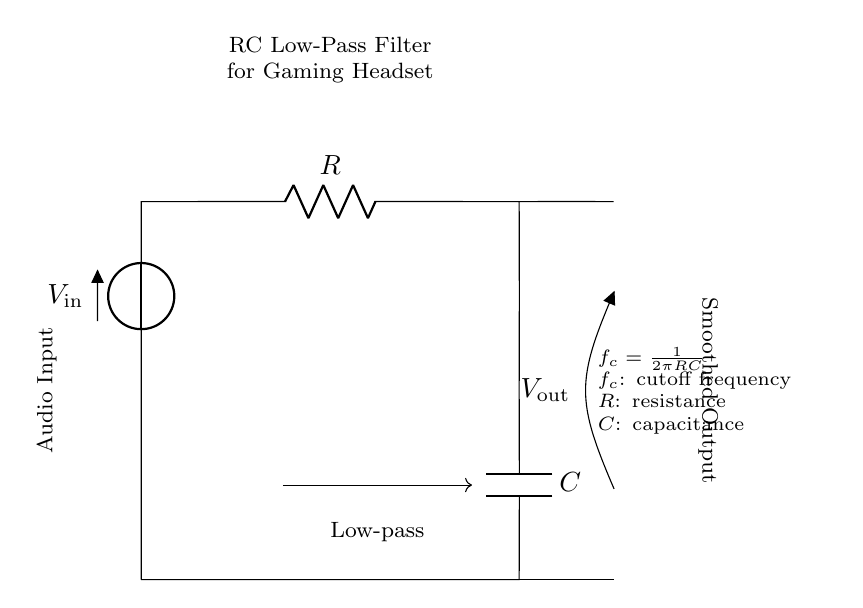What is the component labeled R in the circuit? The component labeled R represents a resistor, which is used to limit the flow of current and create a voltage drop in the circuit.
Answer: Resistor What does the C in the circuit represent? The C in the circuit represents a capacitor, which stores electrical energy and filters out high-frequency signals, allowing only low frequencies to pass through.
Answer: Capacitor What is the function of the components in this circuit? The components function together to form an RC low-pass filter, which smooths audio signals by allowing low-frequency signals to pass and attenuating high-frequency signals.
Answer: Smoothing audio What is the cutoff frequency formula used in this circuit? The cutoff frequency is determined by the formula f_c = 1/(2πRC), where R is resistance and C is capacitance. This formula helps in understanding how the values of R and C affect the frequency at which signals are attenuated.
Answer: f_c = 1/(2πRC) What is the expected output at V_out? The output at V_out is a smoothed version of the input audio signal, where high-frequency noise is reduced. The filter allows the low frequencies (the audio) to pass through while attenuating the higher frequencies.
Answer: Smoothed audio signal What happens to frequencies above the cutoff frequency? Frequencies above the cutoff frequency are attenuated, meaning their amplitude is reduced significantly, which helps to eliminate unwanted noise in the audio signal.
Answer: Attenuated What does the arrow labeled Low-pass indicate? The arrow labeled Low-pass indicates the type of filter this circuit is, which allows low-frequency signals to pass while blocking high-frequency signals to ensure a cleaner audio output.
Answer: Low-pass filter 